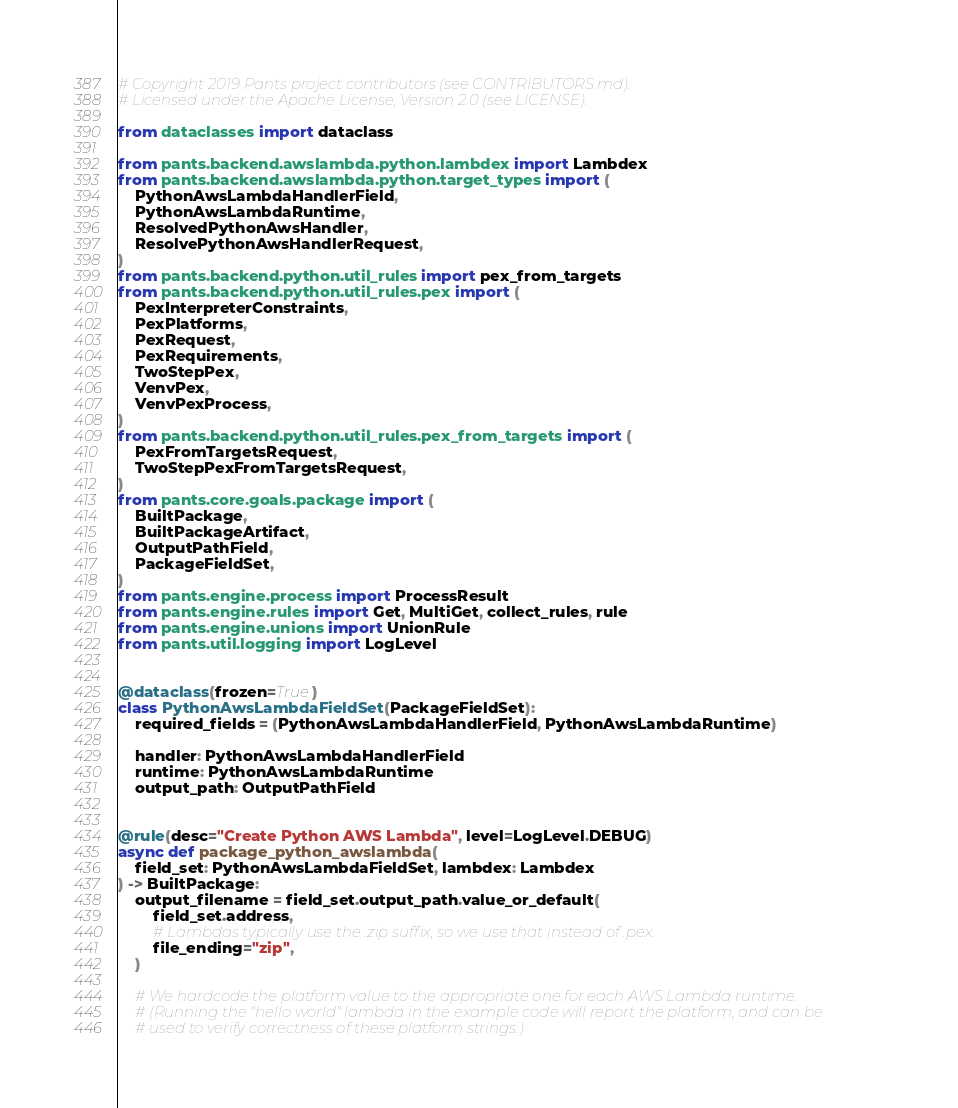<code> <loc_0><loc_0><loc_500><loc_500><_Python_># Copyright 2019 Pants project contributors (see CONTRIBUTORS.md).
# Licensed under the Apache License, Version 2.0 (see LICENSE).

from dataclasses import dataclass

from pants.backend.awslambda.python.lambdex import Lambdex
from pants.backend.awslambda.python.target_types import (
    PythonAwsLambdaHandlerField,
    PythonAwsLambdaRuntime,
    ResolvedPythonAwsHandler,
    ResolvePythonAwsHandlerRequest,
)
from pants.backend.python.util_rules import pex_from_targets
from pants.backend.python.util_rules.pex import (
    PexInterpreterConstraints,
    PexPlatforms,
    PexRequest,
    PexRequirements,
    TwoStepPex,
    VenvPex,
    VenvPexProcess,
)
from pants.backend.python.util_rules.pex_from_targets import (
    PexFromTargetsRequest,
    TwoStepPexFromTargetsRequest,
)
from pants.core.goals.package import (
    BuiltPackage,
    BuiltPackageArtifact,
    OutputPathField,
    PackageFieldSet,
)
from pants.engine.process import ProcessResult
from pants.engine.rules import Get, MultiGet, collect_rules, rule
from pants.engine.unions import UnionRule
from pants.util.logging import LogLevel


@dataclass(frozen=True)
class PythonAwsLambdaFieldSet(PackageFieldSet):
    required_fields = (PythonAwsLambdaHandlerField, PythonAwsLambdaRuntime)

    handler: PythonAwsLambdaHandlerField
    runtime: PythonAwsLambdaRuntime
    output_path: OutputPathField


@rule(desc="Create Python AWS Lambda", level=LogLevel.DEBUG)
async def package_python_awslambda(
    field_set: PythonAwsLambdaFieldSet, lambdex: Lambdex
) -> BuiltPackage:
    output_filename = field_set.output_path.value_or_default(
        field_set.address,
        # Lambdas typically use the .zip suffix, so we use that instead of .pex.
        file_ending="zip",
    )

    # We hardcode the platform value to the appropriate one for each AWS Lambda runtime.
    # (Running the "hello world" lambda in the example code will report the platform, and can be
    # used to verify correctness of these platform strings.)</code> 